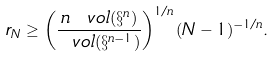<formula> <loc_0><loc_0><loc_500><loc_500>r _ { N } \geq \left ( \frac { n \, \ v o l ( \S ^ { n } ) } { \ v o l ( \S ^ { n - 1 } ) } \right ) ^ { 1 / n } ( N - 1 ) ^ { - 1 / n } .</formula> 